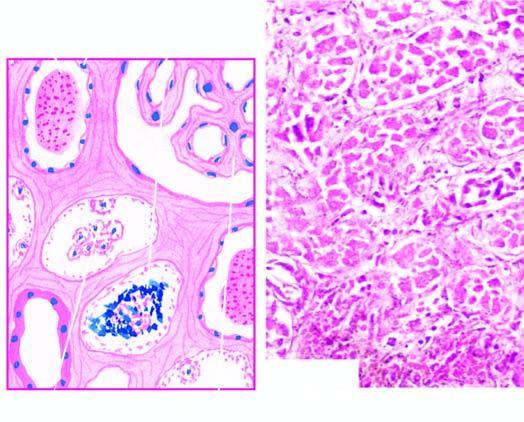what is there involving predominantly proximal convoluted tubule diffusely?
Answer the question using a single word or phrase. Extensive necrosis of epithelial cells 